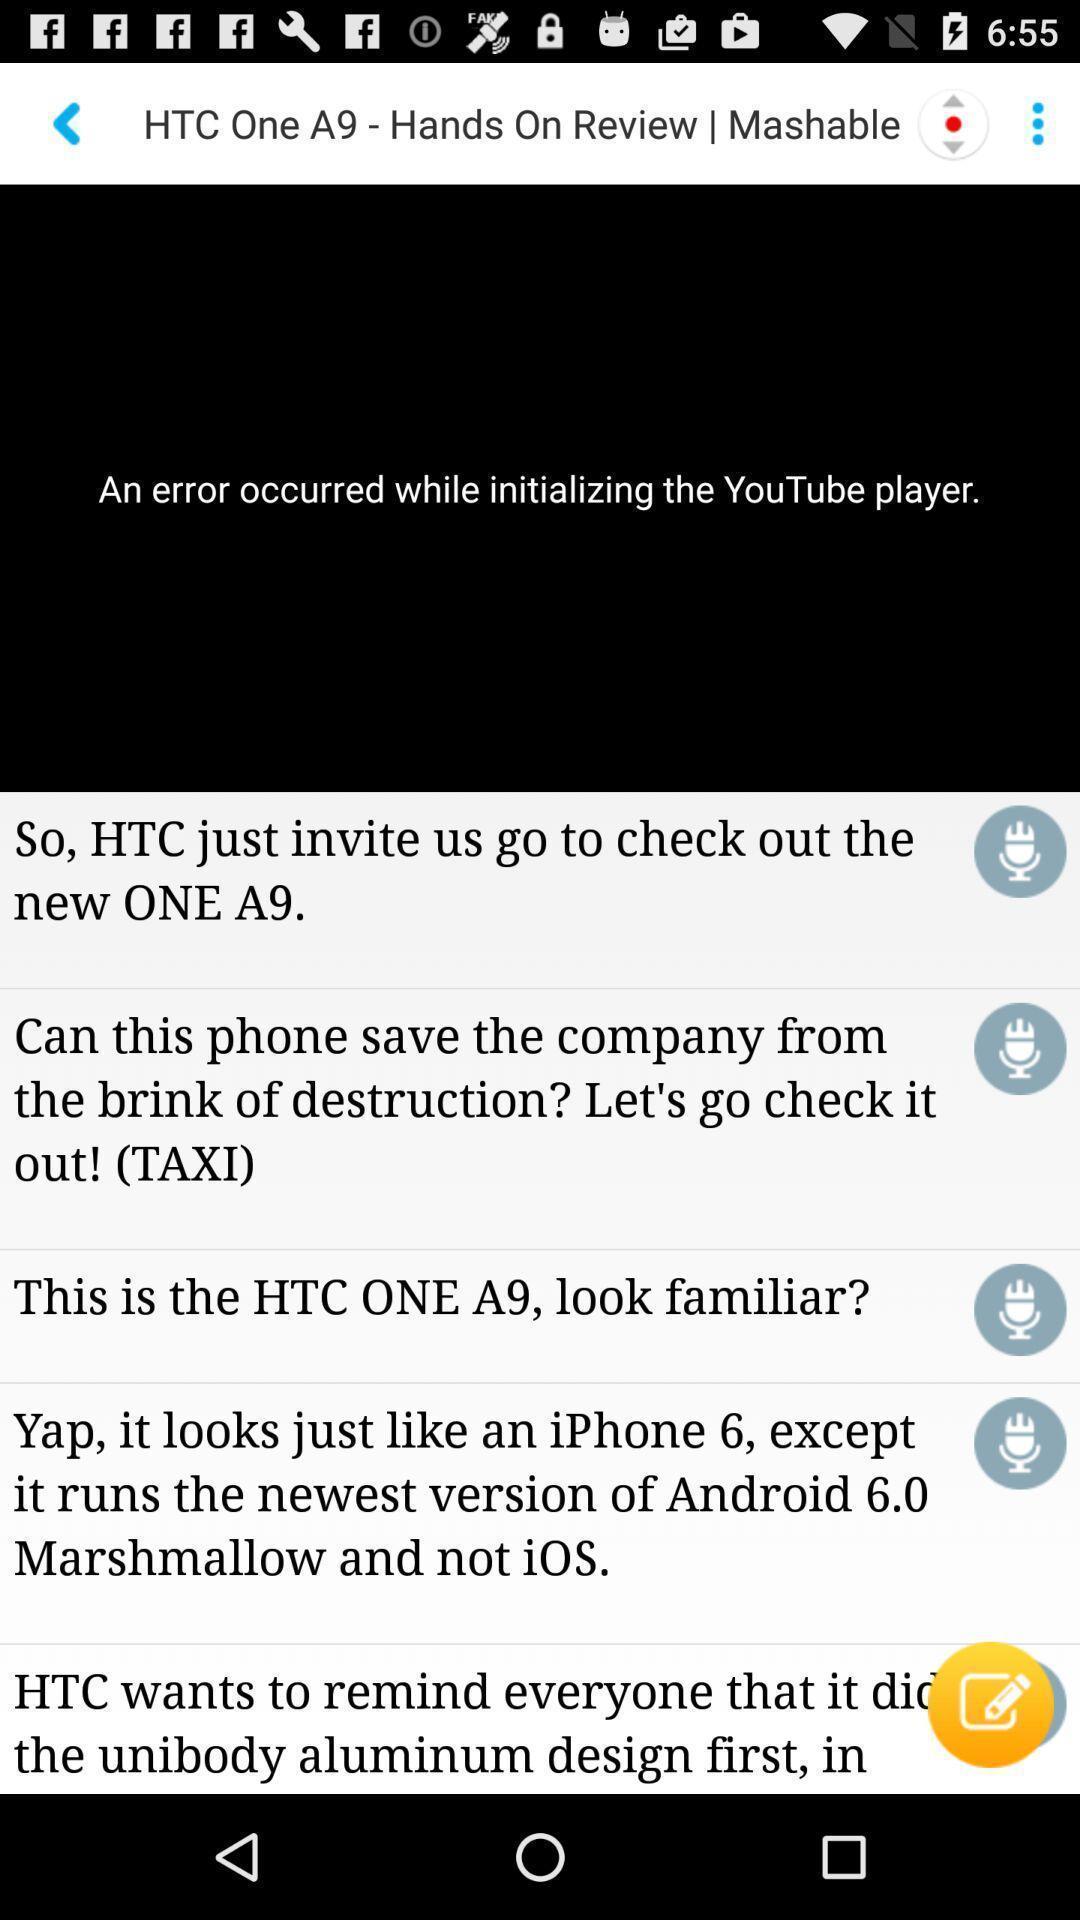Provide a detailed account of this screenshot. Page showing list of articles on a learning app. 